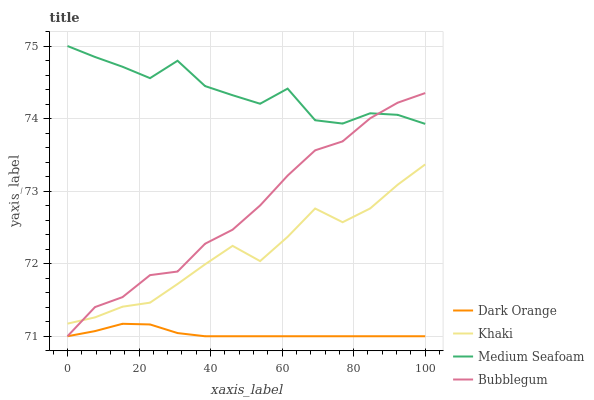Does Khaki have the minimum area under the curve?
Answer yes or no. No. Does Khaki have the maximum area under the curve?
Answer yes or no. No. Is Khaki the smoothest?
Answer yes or no. No. Is Khaki the roughest?
Answer yes or no. No. Does Khaki have the lowest value?
Answer yes or no. No. Does Khaki have the highest value?
Answer yes or no. No. Is Dark Orange less than Medium Seafoam?
Answer yes or no. Yes. Is Medium Seafoam greater than Dark Orange?
Answer yes or no. Yes. Does Dark Orange intersect Medium Seafoam?
Answer yes or no. No. 